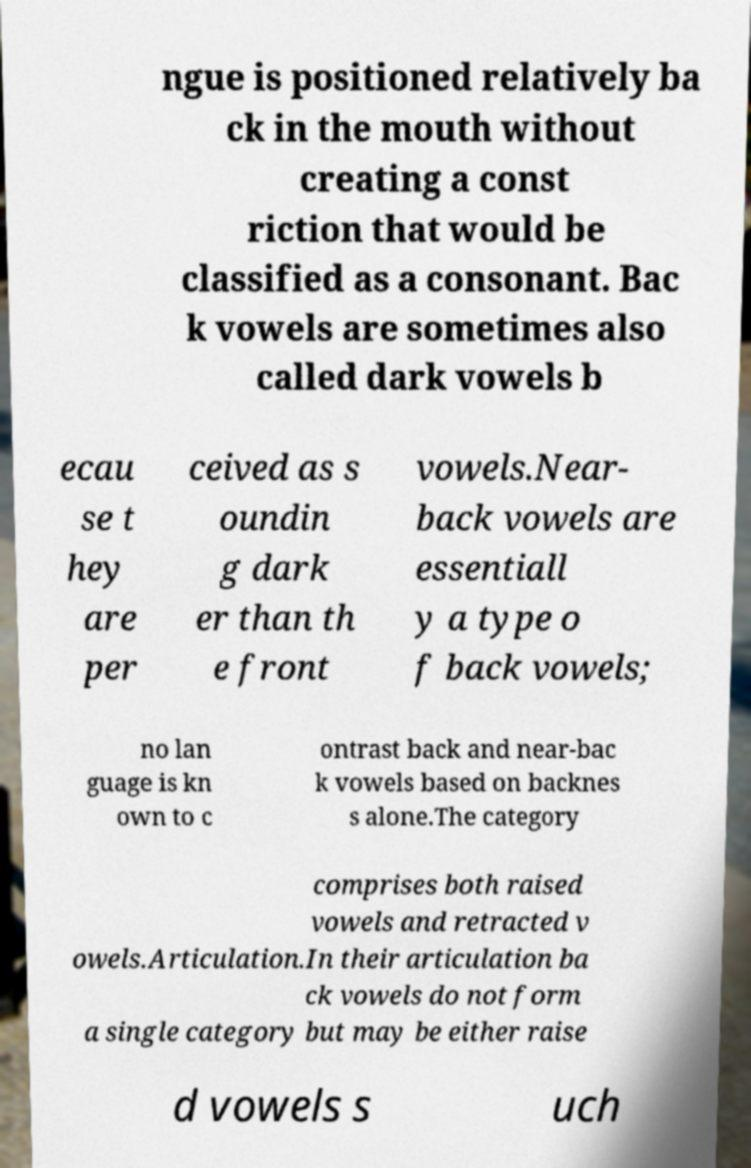Can you accurately transcribe the text from the provided image for me? ngue is positioned relatively ba ck in the mouth without creating a const riction that would be classified as a consonant. Bac k vowels are sometimes also called dark vowels b ecau se t hey are per ceived as s oundin g dark er than th e front vowels.Near- back vowels are essentiall y a type o f back vowels; no lan guage is kn own to c ontrast back and near-bac k vowels based on backnes s alone.The category comprises both raised vowels and retracted v owels.Articulation.In their articulation ba ck vowels do not form a single category but may be either raise d vowels s uch 